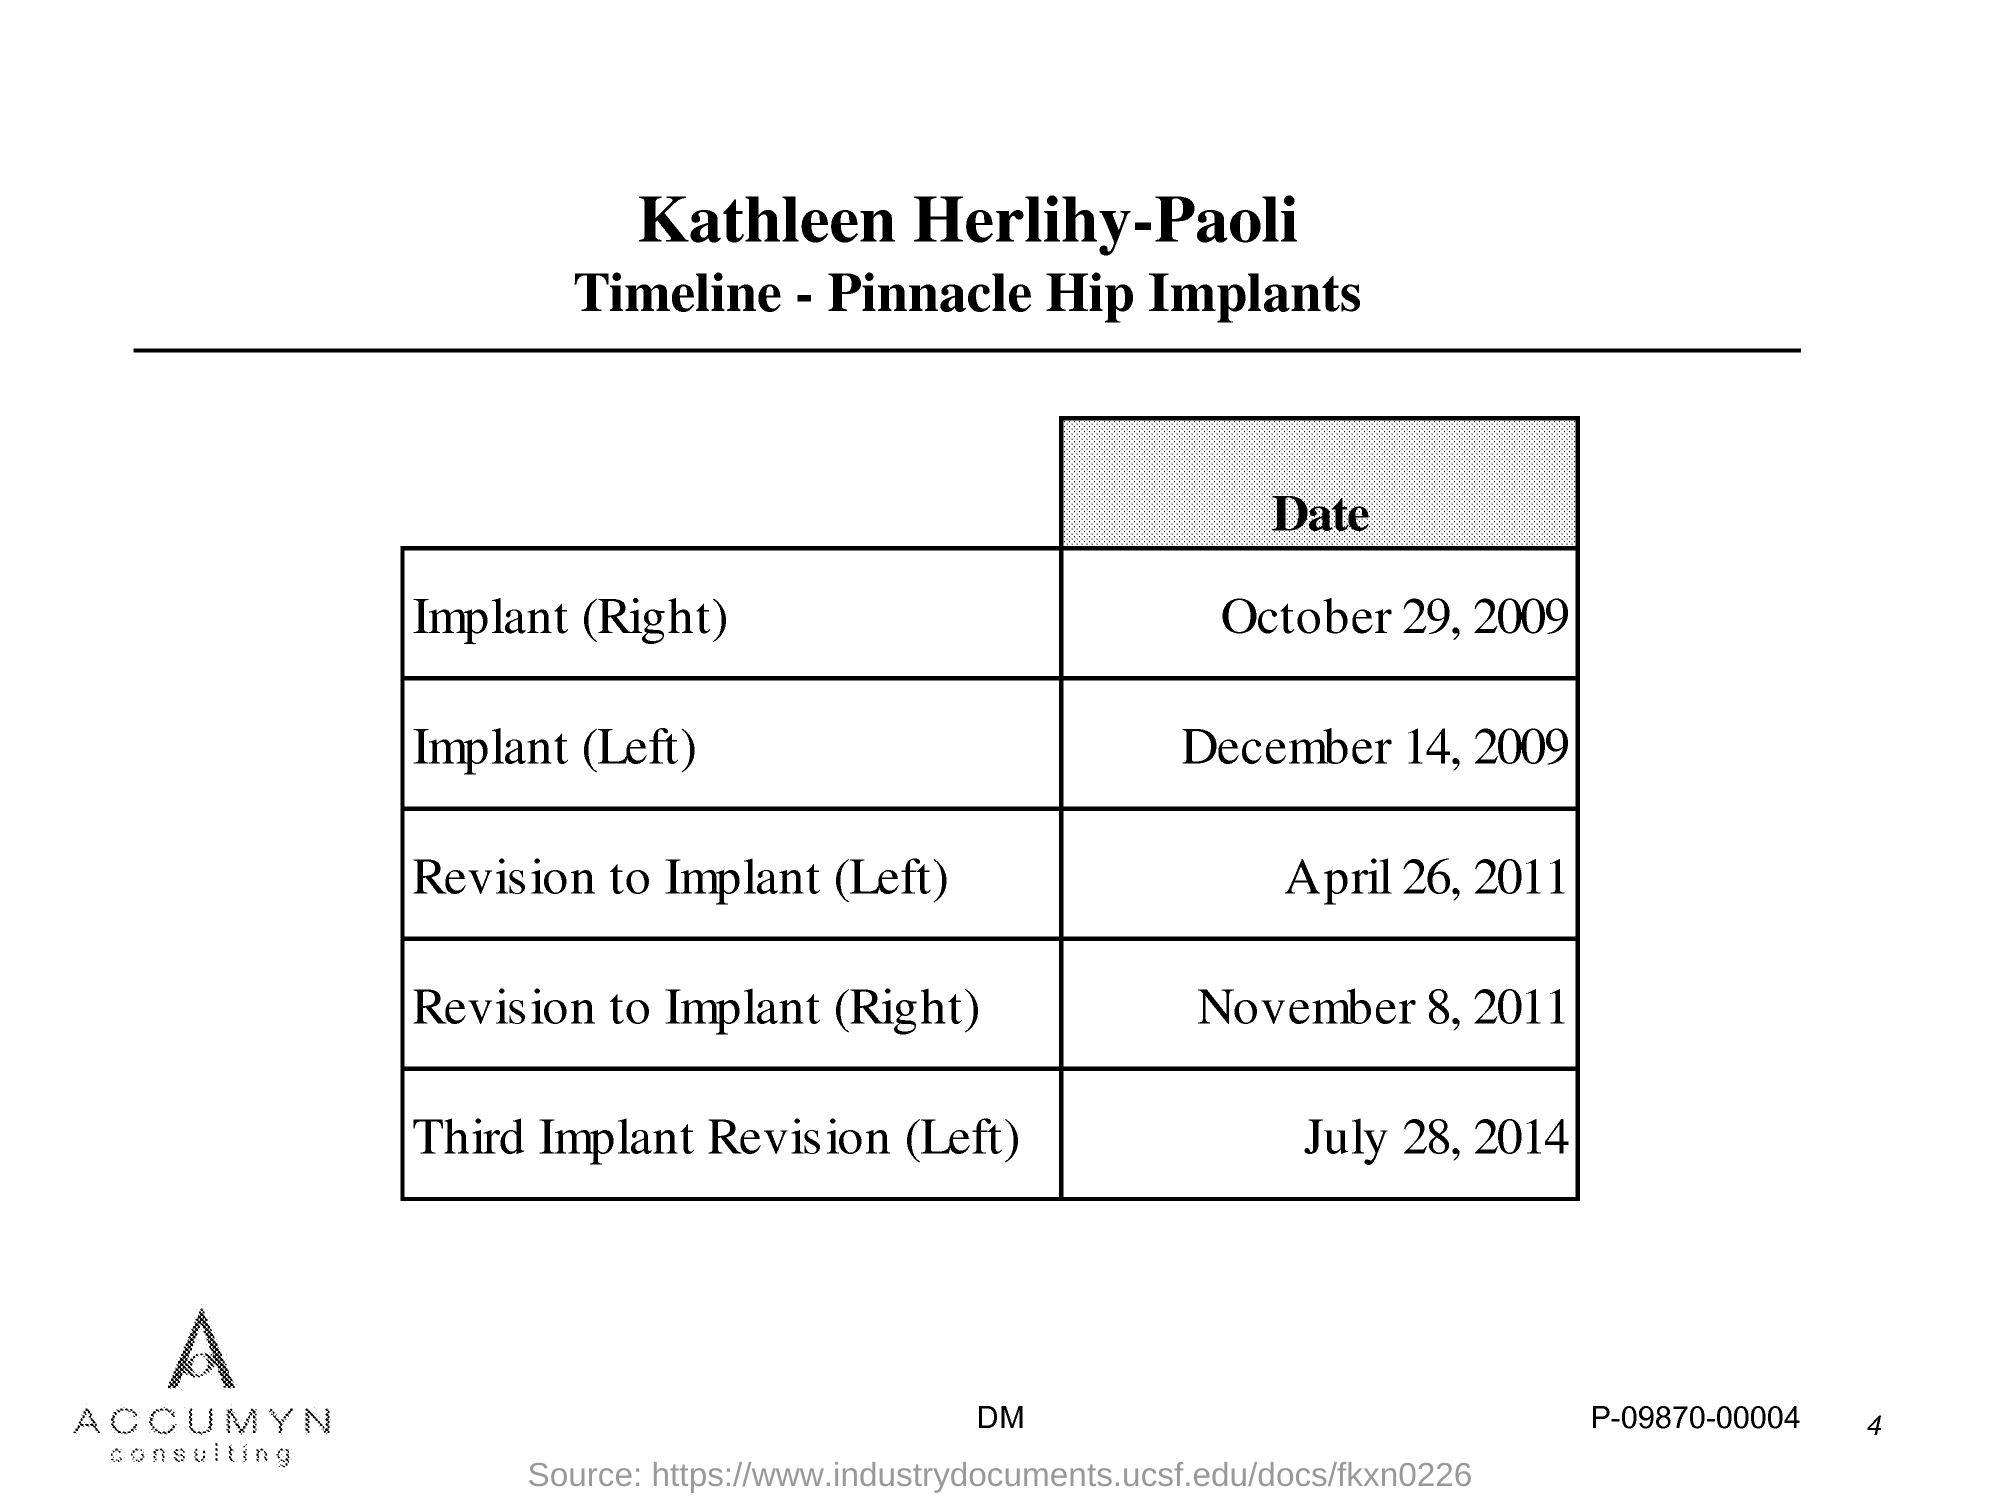What is the Date of Implant (Right)?
Your answer should be compact. October 29, 2009. What is the Date of Implant (left)?
Offer a terse response. December 14, 2009. What is the Date of Revision to Implant (Right)?
Ensure brevity in your answer.  November 8, 2011. What is the Date of Revision to Implant (Left)?
Offer a terse response. April 26, 2011. 